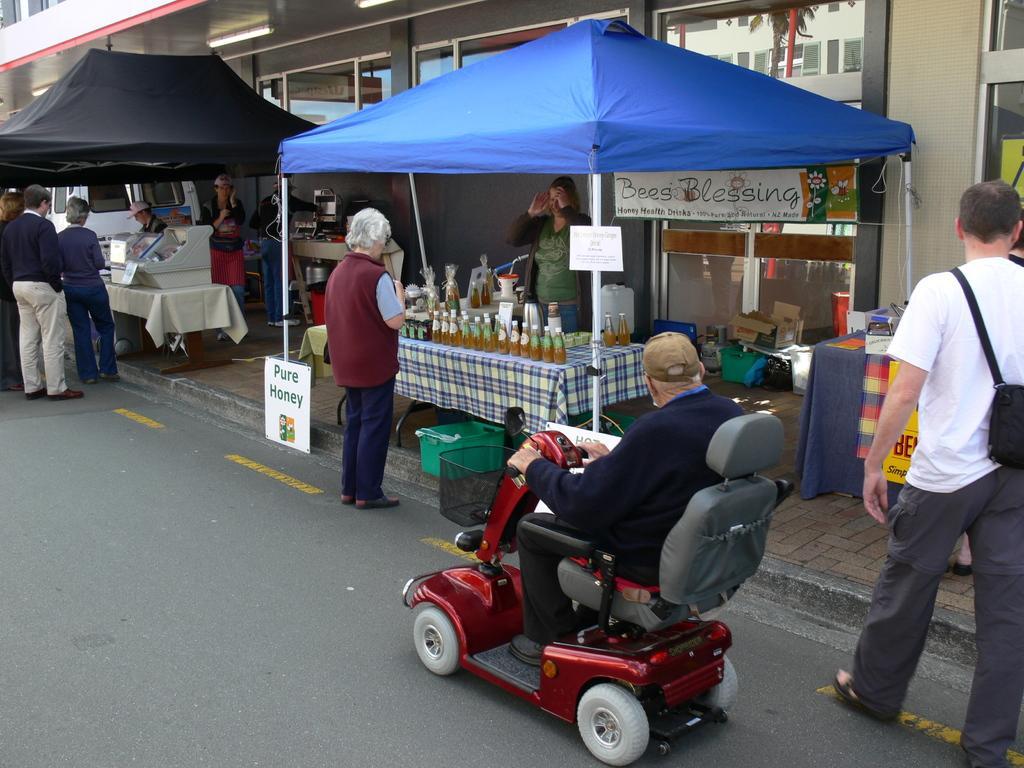Can you describe this image briefly? In the picture we can see a road and beside it, we can see a path with some stalls and some people selling some items and some are watching them and on the road we can see a man sitting on the small cart which is red in color, and he is wearing a cap and behind the stalls we can see a building with glass windows to it. 